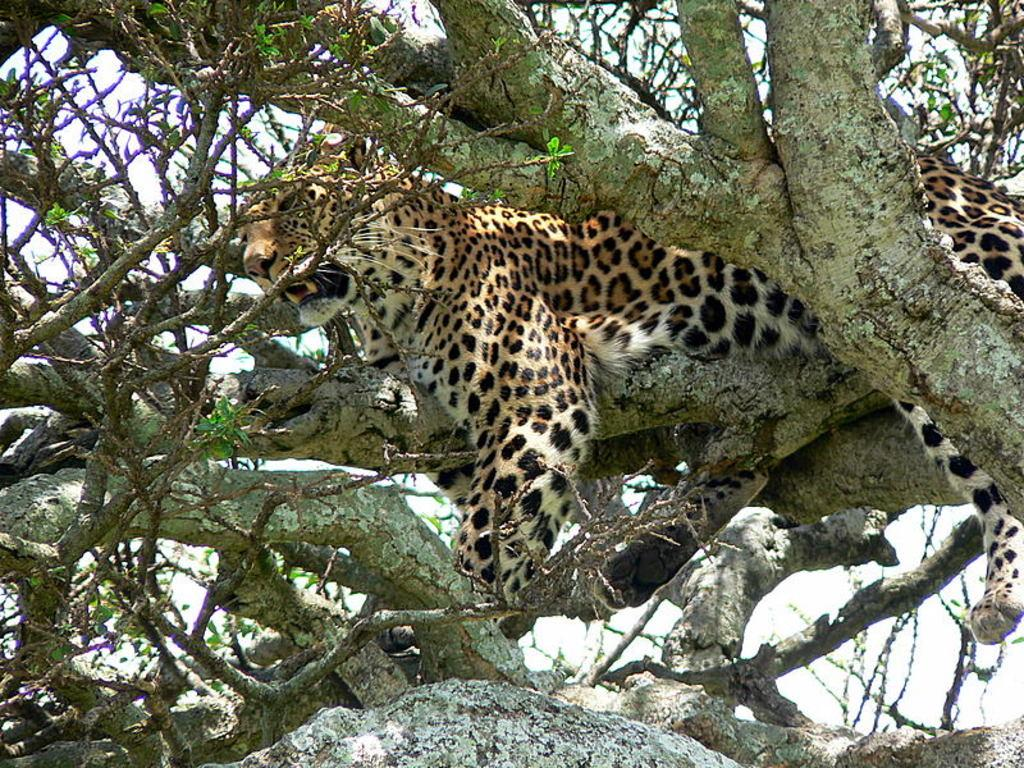What animal is in the picture? There is a tiger in the picture. What type of natural environment is depicted in the picture? There are trees in the picture, suggesting a forest or jungle setting. What can be seen in the background of the picture? The sky is visible in the background of the picture. What type of bone can be seen in the tiger's mouth in the picture? There is no bone present in the picture; it only shows a tiger and trees in the background. 